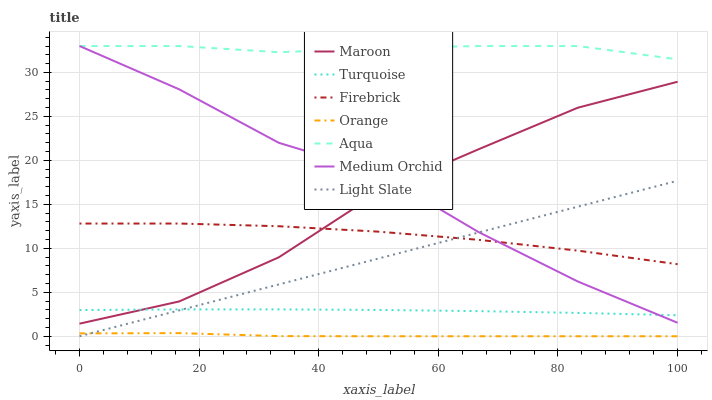Does Light Slate have the minimum area under the curve?
Answer yes or no. No. Does Light Slate have the maximum area under the curve?
Answer yes or no. No. Is Firebrick the smoothest?
Answer yes or no. No. Is Firebrick the roughest?
Answer yes or no. No. Does Firebrick have the lowest value?
Answer yes or no. No. Does Light Slate have the highest value?
Answer yes or no. No. Is Maroon less than Aqua?
Answer yes or no. Yes. Is Aqua greater than Firebrick?
Answer yes or no. Yes. Does Maroon intersect Aqua?
Answer yes or no. No. 